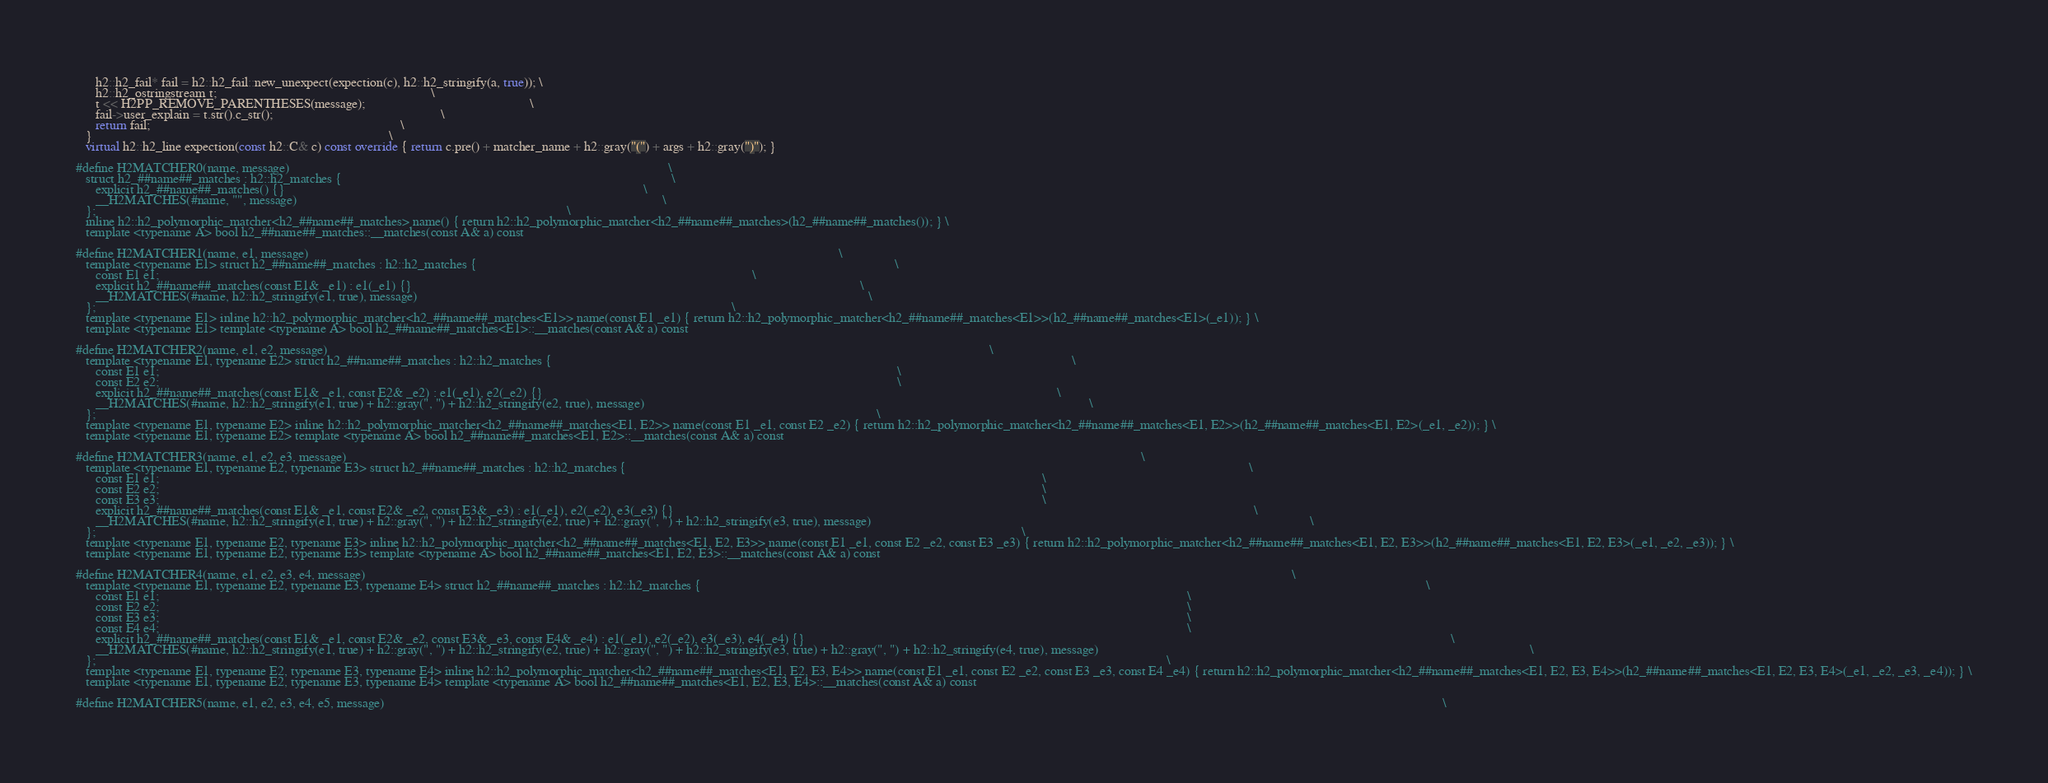Convert code to text. <code><loc_0><loc_0><loc_500><loc_500><_C++_>      h2::h2_fail* fail = h2::h2_fail::new_unexpect(expection(c), h2::h2_stringify(a, true)); \
      h2::h2_ostringstream t;                                                                 \
      t << H2PP_REMOVE_PARENTHESES(message);                                                  \
      fail->user_explain = t.str().c_str();                                                   \
      return fail;                                                                            \
   }                                                                                          \
   virtual h2::h2_line expection(const h2::C& c) const override { return c.pre() + matcher_name + h2::gray("(") + args + h2::gray(")"); }

#define H2MATCHER0(name, message)                                                                                                                   \
   struct h2_##name##_matches : h2::h2_matches {                                                                                                    \
      explicit h2_##name##_matches() {}                                                                                                             \
      __H2MATCHES(#name, "", message)                                                                                                               \
   };                                                                                                                                               \
   inline h2::h2_polymorphic_matcher<h2_##name##_matches> name() { return h2::h2_polymorphic_matcher<h2_##name##_matches>(h2_##name##_matches()); } \
   template <typename A> bool h2_##name##_matches::__matches(const A& a) const

#define H2MATCHER1(name, e1, message)                                                                                                                                                                 \
   template <typename E1> struct h2_##name##_matches : h2::h2_matches {                                                                                                                               \
      const E1 e1;                                                                                                                                                                                    \
      explicit h2_##name##_matches(const E1& _e1) : e1(_e1) {}                                                                                                                                        \
      __H2MATCHES(#name, h2::h2_stringify(e1, true), message)                                                                                                                                         \
   };                                                                                                                                                                                                 \
   template <typename E1> inline h2::h2_polymorphic_matcher<h2_##name##_matches<E1>> name(const E1 _e1) { return h2::h2_polymorphic_matcher<h2_##name##_matches<E1>>(h2_##name##_matches<E1>(_e1)); } \
   template <typename E1> template <typename A> bool h2_##name##_matches<E1>::__matches(const A& a) const

#define H2MATCHER2(name, e1, e2, message)                                                                                                                                                                                                         \
   template <typename E1, typename E2> struct h2_##name##_matches : h2::h2_matches {                                                                                                                                                              \
      const E1 e1;                                                                                                                                                                                                                                \
      const E2 e2;                                                                                                                                                                                                                                \
      explicit h2_##name##_matches(const E1& _e1, const E2& _e2) : e1(_e1), e2(_e2) {}                                                                                                                                                            \
      __H2MATCHES(#name, h2::h2_stringify(e1, true) + h2::gray(", ") + h2::h2_stringify(e2, true), message)                                                                                                                                       \
   };                                                                                                                                                                                                                                             \
   template <typename E1, typename E2> inline h2::h2_polymorphic_matcher<h2_##name##_matches<E1, E2>> name(const E1 _e1, const E2 _e2) { return h2::h2_polymorphic_matcher<h2_##name##_matches<E1, E2>>(h2_##name##_matches<E1, E2>(_e1, _e2)); } \
   template <typename E1, typename E2> template <typename A> bool h2_##name##_matches<E1, E2>::__matches(const A& a) const

#define H2MATCHER3(name, e1, e2, e3, message)                                                                                                                                                                                                                                                 \
   template <typename E1, typename E2, typename E3> struct h2_##name##_matches : h2::h2_matches {                                                                                                                                                                                             \
      const E1 e1;                                                                                                                                                                                                                                                                            \
      const E2 e2;                                                                                                                                                                                                                                                                            \
      const E3 e3;                                                                                                                                                                                                                                                                            \
      explicit h2_##name##_matches(const E1& _e1, const E2& _e2, const E3& _e3) : e1(_e1), e2(_e2), e3(_e3) {}                                                                                                                                                                                \
      __H2MATCHES(#name, h2::h2_stringify(e1, true) + h2::gray(", ") + h2::h2_stringify(e2, true) + h2::gray(", ") + h2::h2_stringify(e3, true), message)                                                                                                                                     \
   };                                                                                                                                                                                                                                                                                         \
   template <typename E1, typename E2, typename E3> inline h2::h2_polymorphic_matcher<h2_##name##_matches<E1, E2, E3>> name(const E1 _e1, const E2 _e2, const E3 _e3) { return h2::h2_polymorphic_matcher<h2_##name##_matches<E1, E2, E3>>(h2_##name##_matches<E1, E2, E3>(_e1, _e2, _e3)); } \
   template <typename E1, typename E2, typename E3> template <typename A> bool h2_##name##_matches<E1, E2, E3>::__matches(const A& a) const

#define H2MATCHER4(name, e1, e2, e3, e4, message)                                                                                                                                                                                                                                                                                         \
   template <typename E1, typename E2, typename E3, typename E4> struct h2_##name##_matches : h2::h2_matches {                                                                                                                                                                                                                            \
      const E1 e1;                                                                                                                                                                                                                                                                                                                        \
      const E2 e2;                                                                                                                                                                                                                                                                                                                        \
      const E3 e3;                                                                                                                                                                                                                                                                                                                        \
      const E4 e4;                                                                                                                                                                                                                                                                                                                        \
      explicit h2_##name##_matches(const E1& _e1, const E2& _e2, const E3& _e3, const E4& _e4) : e1(_e1), e2(_e2), e3(_e3), e4(_e4) {}                                                                                                                                                                                                    \
      __H2MATCHES(#name, h2::h2_stringify(e1, true) + h2::gray(", ") + h2::h2_stringify(e2, true) + h2::gray(", ") + h2::h2_stringify(e3, true) + h2::gray(", ") + h2::h2_stringify(e4, true), message)                                                                                                                                   \
   };                                                                                                                                                                                                                                                                                                                                     \
   template <typename E1, typename E2, typename E3, typename E4> inline h2::h2_polymorphic_matcher<h2_##name##_matches<E1, E2, E3, E4>> name(const E1 _e1, const E2 _e2, const E3 _e3, const E4 _e4) { return h2::h2_polymorphic_matcher<h2_##name##_matches<E1, E2, E3, E4>>(h2_##name##_matches<E1, E2, E3, E4>(_e1, _e2, _e3, _e4)); } \
   template <typename E1, typename E2, typename E3, typename E4> template <typename A> bool h2_##name##_matches<E1, E2, E3, E4>::__matches(const A& a) const

#define H2MATCHER5(name, e1, e2, e3, e4, e5, message)                                                                                                                                                                                                                                                                                                                                 \</code> 